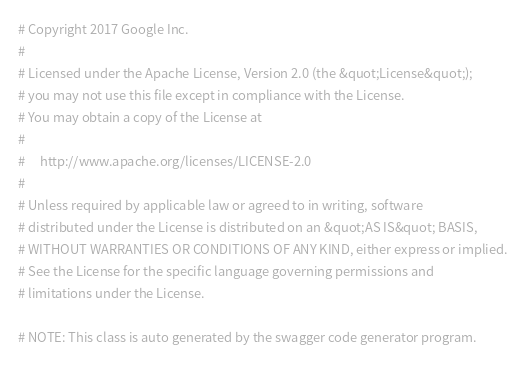<code> <loc_0><loc_0><loc_500><loc_500><_Elixir_># Copyright 2017 Google Inc.
#
# Licensed under the Apache License, Version 2.0 (the &quot;License&quot;);
# you may not use this file except in compliance with the License.
# You may obtain a copy of the License at
#
#     http://www.apache.org/licenses/LICENSE-2.0
#
# Unless required by applicable law or agreed to in writing, software
# distributed under the License is distributed on an &quot;AS IS&quot; BASIS,
# WITHOUT WARRANTIES OR CONDITIONS OF ANY KIND, either express or implied.
# See the License for the specific language governing permissions and
# limitations under the License.

# NOTE: This class is auto generated by the swagger code generator program.</code> 